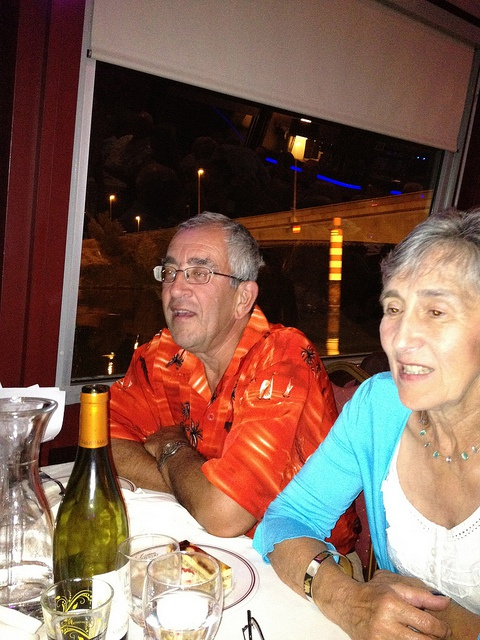Describe the objects in this image and their specific colors. I can see people in black, cyan, ivory, and tan tones, people in black, red, brown, and salmon tones, dining table in black, white, olive, and darkgray tones, bottle in black, olive, white, and maroon tones, and boat in black, maroon, and brown tones in this image. 